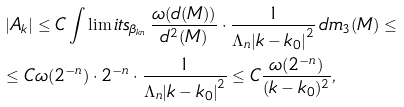<formula> <loc_0><loc_0><loc_500><loc_500>& \left | A _ { k } \right | \leq C \int \lim i t s _ { \beta _ { k n } } \, \frac { \omega ( d ( M ) ) } { d ^ { 2 } ( M ) } \cdot \frac { 1 } { \Lambda _ { n } { | k - k _ { 0 } | } ^ { 2 } } \, d m _ { 3 } ( M ) \leq \\ & \leq C \omega ( 2 ^ { - n } ) \cdot 2 ^ { - n } \cdot \frac { 1 } { \Lambda _ { n } { | k - k _ { 0 } | } ^ { 2 } } \leq C \frac { \omega ( 2 ^ { - n } ) } { ( k - k _ { 0 } ) ^ { 2 } } ,</formula> 